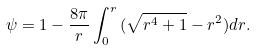Convert formula to latex. <formula><loc_0><loc_0><loc_500><loc_500>\psi = 1 - \frac { 8 \pi } { r } \int _ { 0 } ^ { r } { ( \sqrt { r ^ { 4 } + 1 } - r ^ { 2 } ) d r } .</formula> 